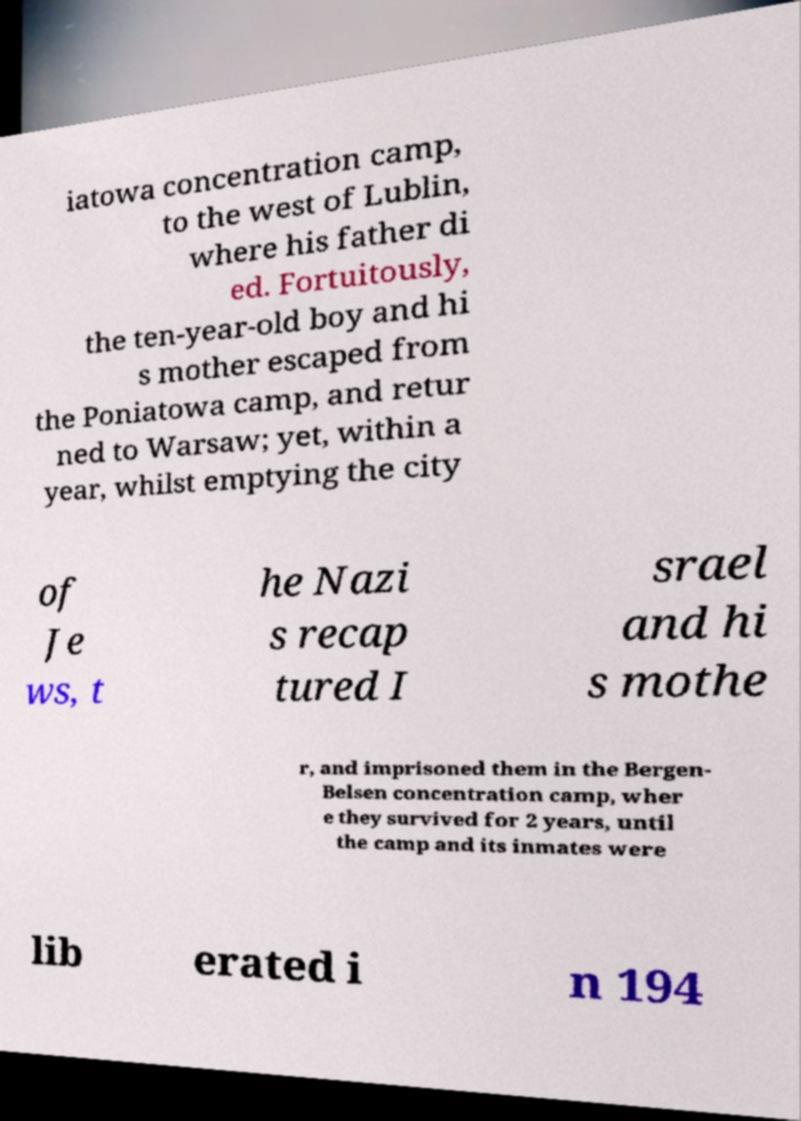There's text embedded in this image that I need extracted. Can you transcribe it verbatim? iatowa concentration camp, to the west of Lublin, where his father di ed. Fortuitously, the ten-year-old boy and hi s mother escaped from the Poniatowa camp, and retur ned to Warsaw; yet, within a year, whilst emptying the city of Je ws, t he Nazi s recap tured I srael and hi s mothe r, and imprisoned them in the Bergen- Belsen concentration camp, wher e they survived for 2 years, until the camp and its inmates were lib erated i n 194 